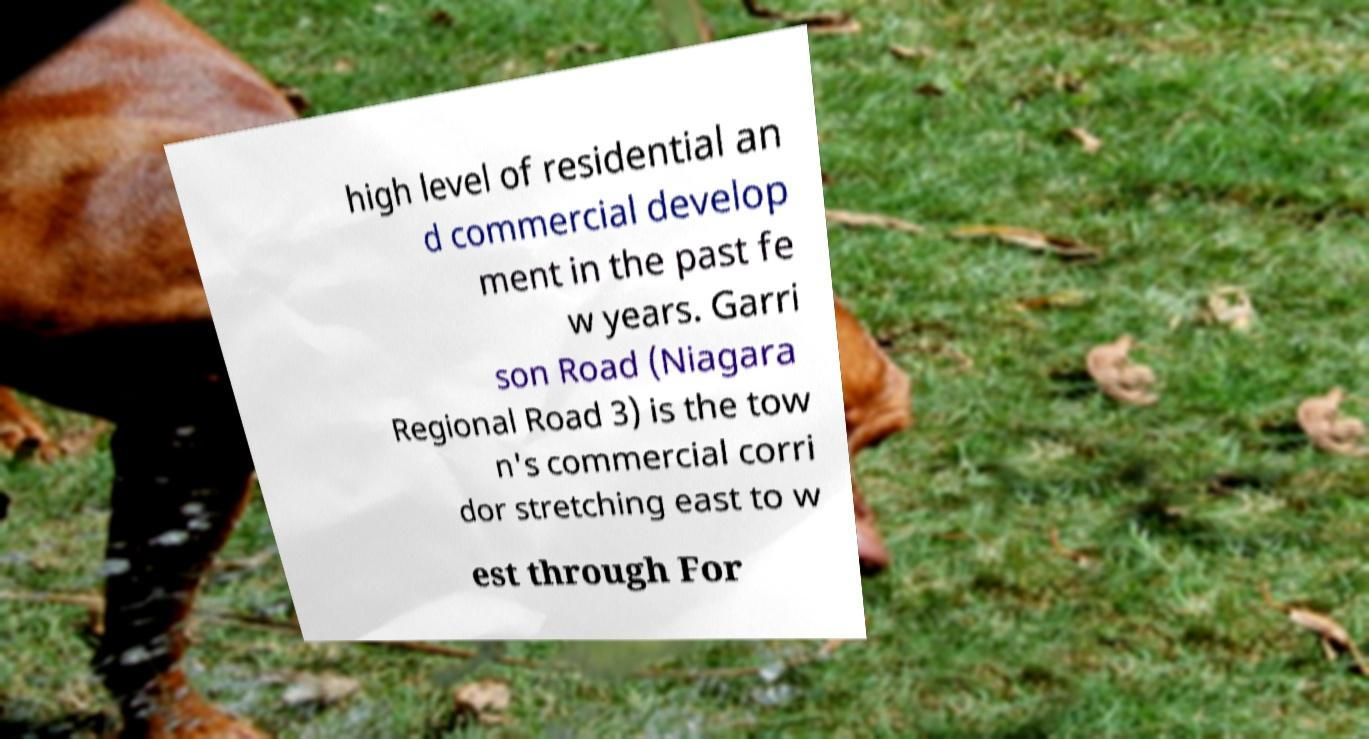Could you assist in decoding the text presented in this image and type it out clearly? high level of residential an d commercial develop ment in the past fe w years. Garri son Road (Niagara Regional Road 3) is the tow n's commercial corri dor stretching east to w est through For 